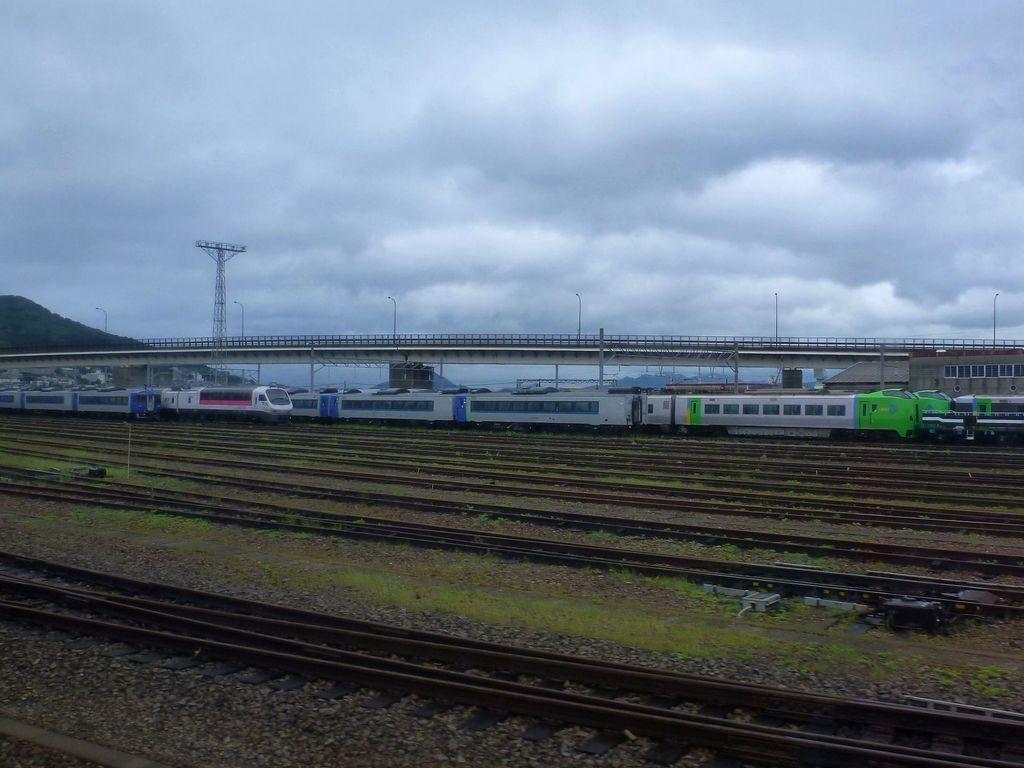Describe this image in one or two sentences. This picture is clicked outside. In the foreground we can see the green grass, gravel and the railway tracks. In the center we can see the trains seems to be running on the railway tracks and we can see the poles, bridge, lamp posts, and in the background we can see the sky which is full of clouds and we can see the trees and some other objects and the buildings. 